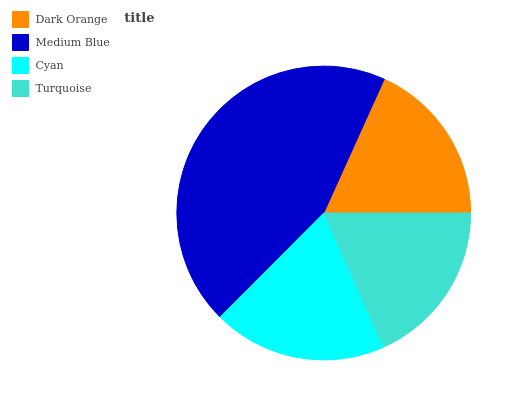Is Dark Orange the minimum?
Answer yes or no. Yes. Is Medium Blue the maximum?
Answer yes or no. Yes. Is Cyan the minimum?
Answer yes or no. No. Is Cyan the maximum?
Answer yes or no. No. Is Medium Blue greater than Cyan?
Answer yes or no. Yes. Is Cyan less than Medium Blue?
Answer yes or no. Yes. Is Cyan greater than Medium Blue?
Answer yes or no. No. Is Medium Blue less than Cyan?
Answer yes or no. No. Is Cyan the high median?
Answer yes or no. Yes. Is Turquoise the low median?
Answer yes or no. Yes. Is Dark Orange the high median?
Answer yes or no. No. Is Dark Orange the low median?
Answer yes or no. No. 